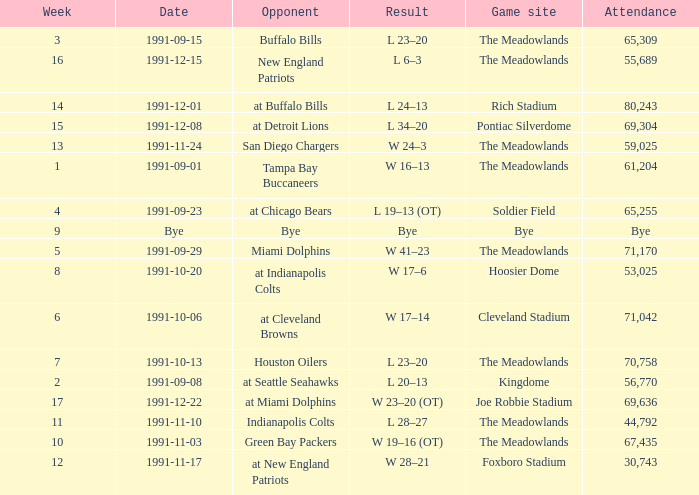What was the Result of the Game at the Meadowlands on 1991-09-01? W 16–13. 